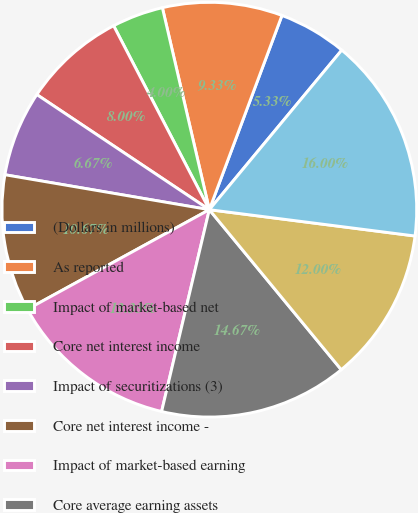<chart> <loc_0><loc_0><loc_500><loc_500><pie_chart><fcel>(Dollars in millions)<fcel>As reported<fcel>Impact of market-based net<fcel>Core net interest income<fcel>Impact of securitizations (3)<fcel>Core net interest income -<fcel>Impact of market-based earning<fcel>Core average earning assets<fcel>Impact of securitizations<fcel>Core average earning assets -<nl><fcel>5.33%<fcel>9.33%<fcel>4.0%<fcel>8.0%<fcel>6.67%<fcel>10.67%<fcel>13.33%<fcel>14.67%<fcel>12.0%<fcel>16.0%<nl></chart> 